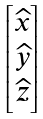Convert formula to latex. <formula><loc_0><loc_0><loc_500><loc_500>\begin{bmatrix} \widehat { x } \\ \widehat { y } \\ \widehat { z } \end{bmatrix}</formula> 